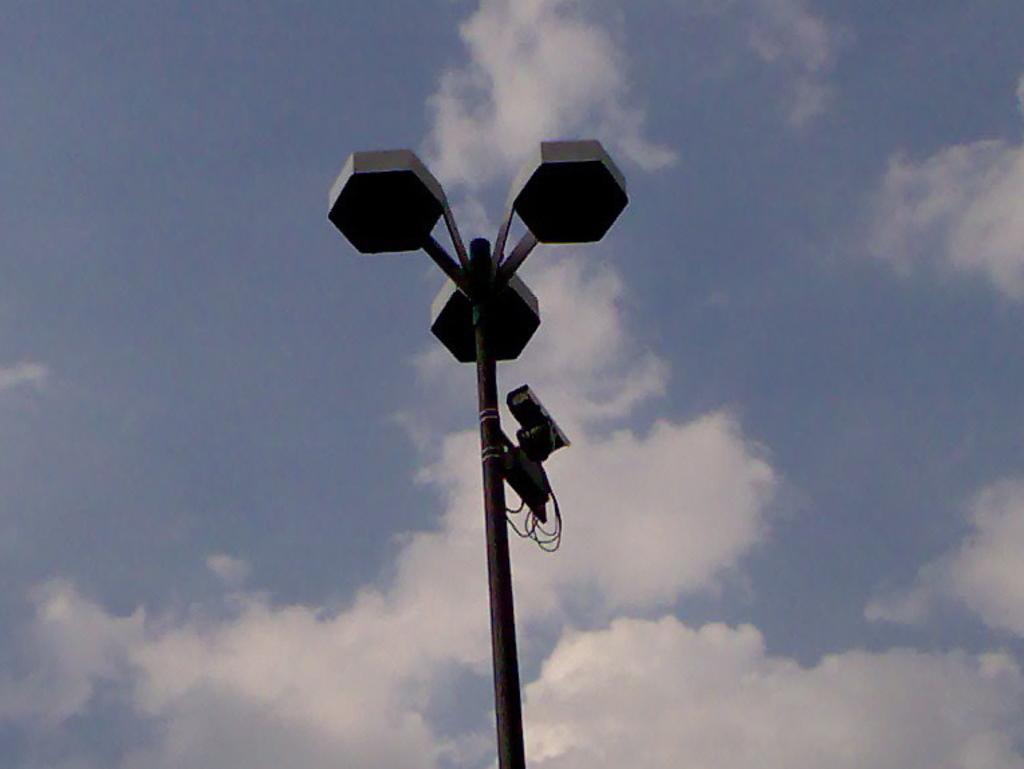Can you describe this image briefly? In this image, in the middle, we can see street light, pole, camera and few electric wires. In the background, we can see a sky which is a bit cloudy. 